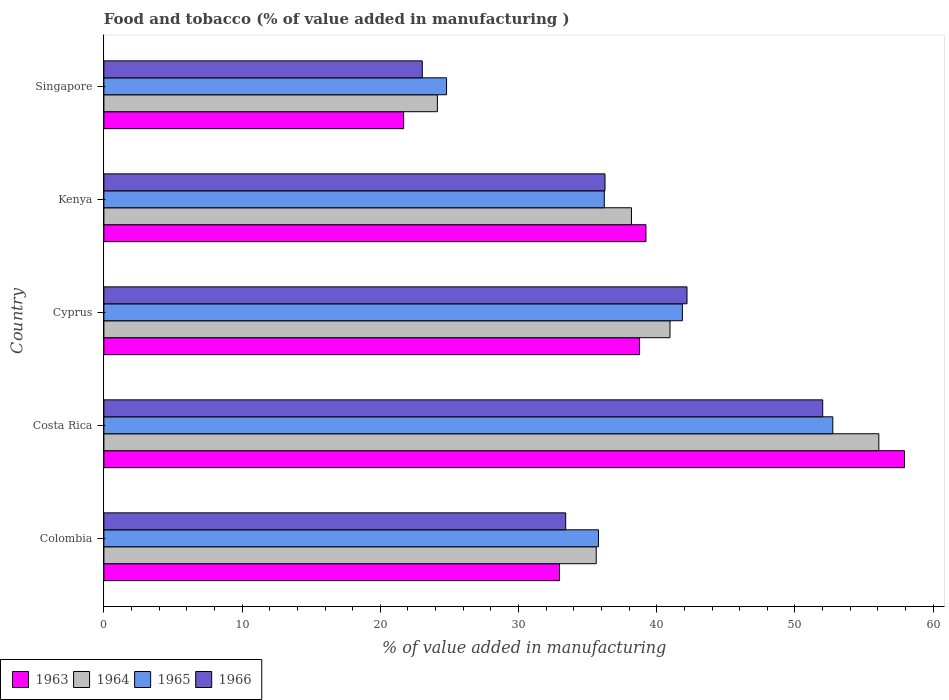How many different coloured bars are there?
Your answer should be compact. 4. Are the number of bars on each tick of the Y-axis equal?
Your answer should be compact. Yes. In how many cases, is the number of bars for a given country not equal to the number of legend labels?
Ensure brevity in your answer.  0. What is the value added in manufacturing food and tobacco in 1963 in Kenya?
Provide a short and direct response. 39.22. Across all countries, what is the maximum value added in manufacturing food and tobacco in 1966?
Keep it short and to the point. 52. Across all countries, what is the minimum value added in manufacturing food and tobacco in 1965?
Ensure brevity in your answer.  24.79. In which country was the value added in manufacturing food and tobacco in 1963 maximum?
Give a very brief answer. Costa Rica. In which country was the value added in manufacturing food and tobacco in 1965 minimum?
Your answer should be compact. Singapore. What is the total value added in manufacturing food and tobacco in 1964 in the graph?
Ensure brevity in your answer.  194.94. What is the difference between the value added in manufacturing food and tobacco in 1965 in Costa Rica and that in Kenya?
Provide a short and direct response. 16.53. What is the difference between the value added in manufacturing food and tobacco in 1964 in Cyprus and the value added in manufacturing food and tobacco in 1963 in Kenya?
Your response must be concise. 1.74. What is the average value added in manufacturing food and tobacco in 1966 per country?
Your answer should be very brief. 37.38. What is the difference between the value added in manufacturing food and tobacco in 1966 and value added in manufacturing food and tobacco in 1964 in Costa Rica?
Make the answer very short. -4.06. In how many countries, is the value added in manufacturing food and tobacco in 1963 greater than 34 %?
Your answer should be very brief. 3. What is the ratio of the value added in manufacturing food and tobacco in 1966 in Cyprus to that in Kenya?
Make the answer very short. 1.16. Is the value added in manufacturing food and tobacco in 1963 in Colombia less than that in Singapore?
Make the answer very short. No. Is the difference between the value added in manufacturing food and tobacco in 1966 in Colombia and Singapore greater than the difference between the value added in manufacturing food and tobacco in 1964 in Colombia and Singapore?
Ensure brevity in your answer.  No. What is the difference between the highest and the second highest value added in manufacturing food and tobacco in 1965?
Offer a terse response. 10.88. What is the difference between the highest and the lowest value added in manufacturing food and tobacco in 1964?
Make the answer very short. 31.94. Is the sum of the value added in manufacturing food and tobacco in 1965 in Cyprus and Kenya greater than the maximum value added in manufacturing food and tobacco in 1964 across all countries?
Your answer should be very brief. Yes. Is it the case that in every country, the sum of the value added in manufacturing food and tobacco in 1966 and value added in manufacturing food and tobacco in 1964 is greater than the sum of value added in manufacturing food and tobacco in 1963 and value added in manufacturing food and tobacco in 1965?
Your response must be concise. No. What does the 2nd bar from the top in Kenya represents?
Give a very brief answer. 1965. What does the 3rd bar from the bottom in Colombia represents?
Ensure brevity in your answer.  1965. Is it the case that in every country, the sum of the value added in manufacturing food and tobacco in 1964 and value added in manufacturing food and tobacco in 1963 is greater than the value added in manufacturing food and tobacco in 1965?
Offer a very short reply. Yes. How many bars are there?
Ensure brevity in your answer.  20. How many countries are there in the graph?
Offer a very short reply. 5. Are the values on the major ticks of X-axis written in scientific E-notation?
Offer a very short reply. No. Does the graph contain grids?
Make the answer very short. No. How many legend labels are there?
Provide a short and direct response. 4. What is the title of the graph?
Your answer should be compact. Food and tobacco (% of value added in manufacturing ). Does "2010" appear as one of the legend labels in the graph?
Provide a succinct answer. No. What is the label or title of the X-axis?
Provide a short and direct response. % of value added in manufacturing. What is the % of value added in manufacturing of 1963 in Colombia?
Your answer should be compact. 32.96. What is the % of value added in manufacturing of 1964 in Colombia?
Ensure brevity in your answer.  35.62. What is the % of value added in manufacturing in 1965 in Colombia?
Your answer should be compact. 35.78. What is the % of value added in manufacturing in 1966 in Colombia?
Offer a terse response. 33.41. What is the % of value added in manufacturing in 1963 in Costa Rica?
Offer a very short reply. 57.92. What is the % of value added in manufacturing in 1964 in Costa Rica?
Ensure brevity in your answer.  56.07. What is the % of value added in manufacturing of 1965 in Costa Rica?
Ensure brevity in your answer.  52.73. What is the % of value added in manufacturing in 1966 in Costa Rica?
Your answer should be very brief. 52. What is the % of value added in manufacturing in 1963 in Cyprus?
Your answer should be compact. 38.75. What is the % of value added in manufacturing of 1964 in Cyprus?
Your answer should be very brief. 40.96. What is the % of value added in manufacturing in 1965 in Cyprus?
Provide a short and direct response. 41.85. What is the % of value added in manufacturing of 1966 in Cyprus?
Provide a succinct answer. 42.19. What is the % of value added in manufacturing in 1963 in Kenya?
Your answer should be compact. 39.22. What is the % of value added in manufacturing of 1964 in Kenya?
Keep it short and to the point. 38.17. What is the % of value added in manufacturing in 1965 in Kenya?
Keep it short and to the point. 36.2. What is the % of value added in manufacturing in 1966 in Kenya?
Your answer should be very brief. 36.25. What is the % of value added in manufacturing of 1963 in Singapore?
Your response must be concise. 21.69. What is the % of value added in manufacturing of 1964 in Singapore?
Offer a terse response. 24.13. What is the % of value added in manufacturing in 1965 in Singapore?
Your answer should be compact. 24.79. What is the % of value added in manufacturing in 1966 in Singapore?
Your answer should be very brief. 23.04. Across all countries, what is the maximum % of value added in manufacturing in 1963?
Keep it short and to the point. 57.92. Across all countries, what is the maximum % of value added in manufacturing of 1964?
Keep it short and to the point. 56.07. Across all countries, what is the maximum % of value added in manufacturing in 1965?
Your answer should be very brief. 52.73. Across all countries, what is the maximum % of value added in manufacturing of 1966?
Ensure brevity in your answer.  52. Across all countries, what is the minimum % of value added in manufacturing in 1963?
Ensure brevity in your answer.  21.69. Across all countries, what is the minimum % of value added in manufacturing of 1964?
Your answer should be very brief. 24.13. Across all countries, what is the minimum % of value added in manufacturing in 1965?
Provide a succinct answer. 24.79. Across all countries, what is the minimum % of value added in manufacturing in 1966?
Offer a terse response. 23.04. What is the total % of value added in manufacturing in 1963 in the graph?
Keep it short and to the point. 190.54. What is the total % of value added in manufacturing in 1964 in the graph?
Your response must be concise. 194.94. What is the total % of value added in manufacturing in 1965 in the graph?
Keep it short and to the point. 191.36. What is the total % of value added in manufacturing of 1966 in the graph?
Give a very brief answer. 186.89. What is the difference between the % of value added in manufacturing in 1963 in Colombia and that in Costa Rica?
Your response must be concise. -24.96. What is the difference between the % of value added in manufacturing in 1964 in Colombia and that in Costa Rica?
Provide a succinct answer. -20.45. What is the difference between the % of value added in manufacturing in 1965 in Colombia and that in Costa Rica?
Your answer should be compact. -16.95. What is the difference between the % of value added in manufacturing of 1966 in Colombia and that in Costa Rica?
Keep it short and to the point. -18.59. What is the difference between the % of value added in manufacturing in 1963 in Colombia and that in Cyprus?
Your response must be concise. -5.79. What is the difference between the % of value added in manufacturing in 1964 in Colombia and that in Cyprus?
Your answer should be compact. -5.34. What is the difference between the % of value added in manufacturing in 1965 in Colombia and that in Cyprus?
Offer a terse response. -6.07. What is the difference between the % of value added in manufacturing in 1966 in Colombia and that in Cyprus?
Your response must be concise. -8.78. What is the difference between the % of value added in manufacturing of 1963 in Colombia and that in Kenya?
Offer a very short reply. -6.26. What is the difference between the % of value added in manufacturing of 1964 in Colombia and that in Kenya?
Provide a short and direct response. -2.55. What is the difference between the % of value added in manufacturing of 1965 in Colombia and that in Kenya?
Your answer should be very brief. -0.42. What is the difference between the % of value added in manufacturing in 1966 in Colombia and that in Kenya?
Your answer should be compact. -2.84. What is the difference between the % of value added in manufacturing in 1963 in Colombia and that in Singapore?
Your response must be concise. 11.27. What is the difference between the % of value added in manufacturing in 1964 in Colombia and that in Singapore?
Your answer should be compact. 11.49. What is the difference between the % of value added in manufacturing of 1965 in Colombia and that in Singapore?
Provide a short and direct response. 10.99. What is the difference between the % of value added in manufacturing in 1966 in Colombia and that in Singapore?
Your answer should be compact. 10.37. What is the difference between the % of value added in manufacturing in 1963 in Costa Rica and that in Cyprus?
Provide a short and direct response. 19.17. What is the difference between the % of value added in manufacturing in 1964 in Costa Rica and that in Cyprus?
Keep it short and to the point. 15.11. What is the difference between the % of value added in manufacturing of 1965 in Costa Rica and that in Cyprus?
Your answer should be compact. 10.88. What is the difference between the % of value added in manufacturing of 1966 in Costa Rica and that in Cyprus?
Keep it short and to the point. 9.82. What is the difference between the % of value added in manufacturing in 1963 in Costa Rica and that in Kenya?
Provide a succinct answer. 18.7. What is the difference between the % of value added in manufacturing in 1964 in Costa Rica and that in Kenya?
Your answer should be very brief. 17.9. What is the difference between the % of value added in manufacturing in 1965 in Costa Rica and that in Kenya?
Offer a terse response. 16.53. What is the difference between the % of value added in manufacturing in 1966 in Costa Rica and that in Kenya?
Offer a terse response. 15.75. What is the difference between the % of value added in manufacturing of 1963 in Costa Rica and that in Singapore?
Offer a very short reply. 36.23. What is the difference between the % of value added in manufacturing of 1964 in Costa Rica and that in Singapore?
Your response must be concise. 31.94. What is the difference between the % of value added in manufacturing in 1965 in Costa Rica and that in Singapore?
Ensure brevity in your answer.  27.94. What is the difference between the % of value added in manufacturing in 1966 in Costa Rica and that in Singapore?
Make the answer very short. 28.97. What is the difference between the % of value added in manufacturing of 1963 in Cyprus and that in Kenya?
Make the answer very short. -0.46. What is the difference between the % of value added in manufacturing in 1964 in Cyprus and that in Kenya?
Offer a terse response. 2.79. What is the difference between the % of value added in manufacturing of 1965 in Cyprus and that in Kenya?
Your answer should be compact. 5.65. What is the difference between the % of value added in manufacturing of 1966 in Cyprus and that in Kenya?
Your answer should be compact. 5.93. What is the difference between the % of value added in manufacturing of 1963 in Cyprus and that in Singapore?
Your answer should be compact. 17.07. What is the difference between the % of value added in manufacturing of 1964 in Cyprus and that in Singapore?
Your answer should be very brief. 16.83. What is the difference between the % of value added in manufacturing in 1965 in Cyprus and that in Singapore?
Make the answer very short. 17.06. What is the difference between the % of value added in manufacturing of 1966 in Cyprus and that in Singapore?
Give a very brief answer. 19.15. What is the difference between the % of value added in manufacturing of 1963 in Kenya and that in Singapore?
Keep it short and to the point. 17.53. What is the difference between the % of value added in manufacturing in 1964 in Kenya and that in Singapore?
Your answer should be compact. 14.04. What is the difference between the % of value added in manufacturing in 1965 in Kenya and that in Singapore?
Your response must be concise. 11.41. What is the difference between the % of value added in manufacturing in 1966 in Kenya and that in Singapore?
Your response must be concise. 13.22. What is the difference between the % of value added in manufacturing in 1963 in Colombia and the % of value added in manufacturing in 1964 in Costa Rica?
Your answer should be compact. -23.11. What is the difference between the % of value added in manufacturing in 1963 in Colombia and the % of value added in manufacturing in 1965 in Costa Rica?
Ensure brevity in your answer.  -19.77. What is the difference between the % of value added in manufacturing of 1963 in Colombia and the % of value added in manufacturing of 1966 in Costa Rica?
Give a very brief answer. -19.04. What is the difference between the % of value added in manufacturing in 1964 in Colombia and the % of value added in manufacturing in 1965 in Costa Rica?
Offer a very short reply. -17.11. What is the difference between the % of value added in manufacturing in 1964 in Colombia and the % of value added in manufacturing in 1966 in Costa Rica?
Provide a succinct answer. -16.38. What is the difference between the % of value added in manufacturing of 1965 in Colombia and the % of value added in manufacturing of 1966 in Costa Rica?
Provide a succinct answer. -16.22. What is the difference between the % of value added in manufacturing in 1963 in Colombia and the % of value added in manufacturing in 1964 in Cyprus?
Keep it short and to the point. -8. What is the difference between the % of value added in manufacturing in 1963 in Colombia and the % of value added in manufacturing in 1965 in Cyprus?
Offer a very short reply. -8.89. What is the difference between the % of value added in manufacturing of 1963 in Colombia and the % of value added in manufacturing of 1966 in Cyprus?
Your answer should be very brief. -9.23. What is the difference between the % of value added in manufacturing in 1964 in Colombia and the % of value added in manufacturing in 1965 in Cyprus?
Make the answer very short. -6.23. What is the difference between the % of value added in manufacturing in 1964 in Colombia and the % of value added in manufacturing in 1966 in Cyprus?
Your answer should be very brief. -6.57. What is the difference between the % of value added in manufacturing of 1965 in Colombia and the % of value added in manufacturing of 1966 in Cyprus?
Your answer should be compact. -6.41. What is the difference between the % of value added in manufacturing of 1963 in Colombia and the % of value added in manufacturing of 1964 in Kenya?
Offer a very short reply. -5.21. What is the difference between the % of value added in manufacturing in 1963 in Colombia and the % of value added in manufacturing in 1965 in Kenya?
Make the answer very short. -3.24. What is the difference between the % of value added in manufacturing in 1963 in Colombia and the % of value added in manufacturing in 1966 in Kenya?
Keep it short and to the point. -3.29. What is the difference between the % of value added in manufacturing in 1964 in Colombia and the % of value added in manufacturing in 1965 in Kenya?
Offer a terse response. -0.58. What is the difference between the % of value added in manufacturing of 1964 in Colombia and the % of value added in manufacturing of 1966 in Kenya?
Make the answer very short. -0.63. What is the difference between the % of value added in manufacturing in 1965 in Colombia and the % of value added in manufacturing in 1966 in Kenya?
Provide a succinct answer. -0.47. What is the difference between the % of value added in manufacturing of 1963 in Colombia and the % of value added in manufacturing of 1964 in Singapore?
Your answer should be compact. 8.83. What is the difference between the % of value added in manufacturing in 1963 in Colombia and the % of value added in manufacturing in 1965 in Singapore?
Ensure brevity in your answer.  8.17. What is the difference between the % of value added in manufacturing of 1963 in Colombia and the % of value added in manufacturing of 1966 in Singapore?
Provide a succinct answer. 9.92. What is the difference between the % of value added in manufacturing of 1964 in Colombia and the % of value added in manufacturing of 1965 in Singapore?
Make the answer very short. 10.83. What is the difference between the % of value added in manufacturing of 1964 in Colombia and the % of value added in manufacturing of 1966 in Singapore?
Your response must be concise. 12.58. What is the difference between the % of value added in manufacturing in 1965 in Colombia and the % of value added in manufacturing in 1966 in Singapore?
Make the answer very short. 12.74. What is the difference between the % of value added in manufacturing in 1963 in Costa Rica and the % of value added in manufacturing in 1964 in Cyprus?
Your answer should be compact. 16.96. What is the difference between the % of value added in manufacturing of 1963 in Costa Rica and the % of value added in manufacturing of 1965 in Cyprus?
Give a very brief answer. 16.07. What is the difference between the % of value added in manufacturing of 1963 in Costa Rica and the % of value added in manufacturing of 1966 in Cyprus?
Your answer should be compact. 15.73. What is the difference between the % of value added in manufacturing in 1964 in Costa Rica and the % of value added in manufacturing in 1965 in Cyprus?
Offer a very short reply. 14.21. What is the difference between the % of value added in manufacturing in 1964 in Costa Rica and the % of value added in manufacturing in 1966 in Cyprus?
Provide a short and direct response. 13.88. What is the difference between the % of value added in manufacturing of 1965 in Costa Rica and the % of value added in manufacturing of 1966 in Cyprus?
Your response must be concise. 10.55. What is the difference between the % of value added in manufacturing of 1963 in Costa Rica and the % of value added in manufacturing of 1964 in Kenya?
Offer a very short reply. 19.75. What is the difference between the % of value added in manufacturing of 1963 in Costa Rica and the % of value added in manufacturing of 1965 in Kenya?
Provide a short and direct response. 21.72. What is the difference between the % of value added in manufacturing of 1963 in Costa Rica and the % of value added in manufacturing of 1966 in Kenya?
Offer a very short reply. 21.67. What is the difference between the % of value added in manufacturing of 1964 in Costa Rica and the % of value added in manufacturing of 1965 in Kenya?
Your response must be concise. 19.86. What is the difference between the % of value added in manufacturing of 1964 in Costa Rica and the % of value added in manufacturing of 1966 in Kenya?
Offer a very short reply. 19.81. What is the difference between the % of value added in manufacturing of 1965 in Costa Rica and the % of value added in manufacturing of 1966 in Kenya?
Make the answer very short. 16.48. What is the difference between the % of value added in manufacturing in 1963 in Costa Rica and the % of value added in manufacturing in 1964 in Singapore?
Offer a very short reply. 33.79. What is the difference between the % of value added in manufacturing of 1963 in Costa Rica and the % of value added in manufacturing of 1965 in Singapore?
Offer a very short reply. 33.13. What is the difference between the % of value added in manufacturing of 1963 in Costa Rica and the % of value added in manufacturing of 1966 in Singapore?
Make the answer very short. 34.88. What is the difference between the % of value added in manufacturing of 1964 in Costa Rica and the % of value added in manufacturing of 1965 in Singapore?
Keep it short and to the point. 31.28. What is the difference between the % of value added in manufacturing in 1964 in Costa Rica and the % of value added in manufacturing in 1966 in Singapore?
Your answer should be compact. 33.03. What is the difference between the % of value added in manufacturing in 1965 in Costa Rica and the % of value added in manufacturing in 1966 in Singapore?
Your answer should be very brief. 29.7. What is the difference between the % of value added in manufacturing of 1963 in Cyprus and the % of value added in manufacturing of 1964 in Kenya?
Give a very brief answer. 0.59. What is the difference between the % of value added in manufacturing in 1963 in Cyprus and the % of value added in manufacturing in 1965 in Kenya?
Ensure brevity in your answer.  2.55. What is the difference between the % of value added in manufacturing of 1963 in Cyprus and the % of value added in manufacturing of 1966 in Kenya?
Keep it short and to the point. 2.5. What is the difference between the % of value added in manufacturing of 1964 in Cyprus and the % of value added in manufacturing of 1965 in Kenya?
Offer a very short reply. 4.75. What is the difference between the % of value added in manufacturing of 1964 in Cyprus and the % of value added in manufacturing of 1966 in Kenya?
Your response must be concise. 4.7. What is the difference between the % of value added in manufacturing in 1965 in Cyprus and the % of value added in manufacturing in 1966 in Kenya?
Ensure brevity in your answer.  5.6. What is the difference between the % of value added in manufacturing of 1963 in Cyprus and the % of value added in manufacturing of 1964 in Singapore?
Provide a short and direct response. 14.63. What is the difference between the % of value added in manufacturing of 1963 in Cyprus and the % of value added in manufacturing of 1965 in Singapore?
Make the answer very short. 13.96. What is the difference between the % of value added in manufacturing of 1963 in Cyprus and the % of value added in manufacturing of 1966 in Singapore?
Your answer should be compact. 15.72. What is the difference between the % of value added in manufacturing in 1964 in Cyprus and the % of value added in manufacturing in 1965 in Singapore?
Provide a succinct answer. 16.17. What is the difference between the % of value added in manufacturing in 1964 in Cyprus and the % of value added in manufacturing in 1966 in Singapore?
Your response must be concise. 17.92. What is the difference between the % of value added in manufacturing of 1965 in Cyprus and the % of value added in manufacturing of 1966 in Singapore?
Make the answer very short. 18.82. What is the difference between the % of value added in manufacturing of 1963 in Kenya and the % of value added in manufacturing of 1964 in Singapore?
Your response must be concise. 15.09. What is the difference between the % of value added in manufacturing of 1963 in Kenya and the % of value added in manufacturing of 1965 in Singapore?
Provide a succinct answer. 14.43. What is the difference between the % of value added in manufacturing of 1963 in Kenya and the % of value added in manufacturing of 1966 in Singapore?
Provide a short and direct response. 16.18. What is the difference between the % of value added in manufacturing of 1964 in Kenya and the % of value added in manufacturing of 1965 in Singapore?
Keep it short and to the point. 13.38. What is the difference between the % of value added in manufacturing of 1964 in Kenya and the % of value added in manufacturing of 1966 in Singapore?
Keep it short and to the point. 15.13. What is the difference between the % of value added in manufacturing in 1965 in Kenya and the % of value added in manufacturing in 1966 in Singapore?
Make the answer very short. 13.17. What is the average % of value added in manufacturing in 1963 per country?
Offer a very short reply. 38.11. What is the average % of value added in manufacturing of 1964 per country?
Your response must be concise. 38.99. What is the average % of value added in manufacturing in 1965 per country?
Your answer should be very brief. 38.27. What is the average % of value added in manufacturing in 1966 per country?
Make the answer very short. 37.38. What is the difference between the % of value added in manufacturing of 1963 and % of value added in manufacturing of 1964 in Colombia?
Your answer should be very brief. -2.66. What is the difference between the % of value added in manufacturing in 1963 and % of value added in manufacturing in 1965 in Colombia?
Give a very brief answer. -2.82. What is the difference between the % of value added in manufacturing of 1963 and % of value added in manufacturing of 1966 in Colombia?
Keep it short and to the point. -0.45. What is the difference between the % of value added in manufacturing in 1964 and % of value added in manufacturing in 1965 in Colombia?
Ensure brevity in your answer.  -0.16. What is the difference between the % of value added in manufacturing in 1964 and % of value added in manufacturing in 1966 in Colombia?
Ensure brevity in your answer.  2.21. What is the difference between the % of value added in manufacturing in 1965 and % of value added in manufacturing in 1966 in Colombia?
Make the answer very short. 2.37. What is the difference between the % of value added in manufacturing of 1963 and % of value added in manufacturing of 1964 in Costa Rica?
Provide a succinct answer. 1.85. What is the difference between the % of value added in manufacturing of 1963 and % of value added in manufacturing of 1965 in Costa Rica?
Provide a succinct answer. 5.19. What is the difference between the % of value added in manufacturing of 1963 and % of value added in manufacturing of 1966 in Costa Rica?
Your answer should be very brief. 5.92. What is the difference between the % of value added in manufacturing of 1964 and % of value added in manufacturing of 1965 in Costa Rica?
Ensure brevity in your answer.  3.33. What is the difference between the % of value added in manufacturing in 1964 and % of value added in manufacturing in 1966 in Costa Rica?
Your answer should be very brief. 4.06. What is the difference between the % of value added in manufacturing in 1965 and % of value added in manufacturing in 1966 in Costa Rica?
Give a very brief answer. 0.73. What is the difference between the % of value added in manufacturing in 1963 and % of value added in manufacturing in 1964 in Cyprus?
Keep it short and to the point. -2.2. What is the difference between the % of value added in manufacturing in 1963 and % of value added in manufacturing in 1965 in Cyprus?
Offer a terse response. -3.1. What is the difference between the % of value added in manufacturing in 1963 and % of value added in manufacturing in 1966 in Cyprus?
Ensure brevity in your answer.  -3.43. What is the difference between the % of value added in manufacturing in 1964 and % of value added in manufacturing in 1965 in Cyprus?
Your answer should be compact. -0.9. What is the difference between the % of value added in manufacturing of 1964 and % of value added in manufacturing of 1966 in Cyprus?
Your answer should be compact. -1.23. What is the difference between the % of value added in manufacturing of 1965 and % of value added in manufacturing of 1966 in Cyprus?
Make the answer very short. -0.33. What is the difference between the % of value added in manufacturing in 1963 and % of value added in manufacturing in 1964 in Kenya?
Offer a very short reply. 1.05. What is the difference between the % of value added in manufacturing in 1963 and % of value added in manufacturing in 1965 in Kenya?
Keep it short and to the point. 3.01. What is the difference between the % of value added in manufacturing of 1963 and % of value added in manufacturing of 1966 in Kenya?
Ensure brevity in your answer.  2.96. What is the difference between the % of value added in manufacturing in 1964 and % of value added in manufacturing in 1965 in Kenya?
Keep it short and to the point. 1.96. What is the difference between the % of value added in manufacturing in 1964 and % of value added in manufacturing in 1966 in Kenya?
Ensure brevity in your answer.  1.91. What is the difference between the % of value added in manufacturing in 1963 and % of value added in manufacturing in 1964 in Singapore?
Your response must be concise. -2.44. What is the difference between the % of value added in manufacturing in 1963 and % of value added in manufacturing in 1965 in Singapore?
Provide a short and direct response. -3.1. What is the difference between the % of value added in manufacturing of 1963 and % of value added in manufacturing of 1966 in Singapore?
Keep it short and to the point. -1.35. What is the difference between the % of value added in manufacturing of 1964 and % of value added in manufacturing of 1965 in Singapore?
Provide a succinct answer. -0.66. What is the difference between the % of value added in manufacturing of 1964 and % of value added in manufacturing of 1966 in Singapore?
Give a very brief answer. 1.09. What is the difference between the % of value added in manufacturing of 1965 and % of value added in manufacturing of 1966 in Singapore?
Provide a short and direct response. 1.75. What is the ratio of the % of value added in manufacturing in 1963 in Colombia to that in Costa Rica?
Offer a terse response. 0.57. What is the ratio of the % of value added in manufacturing of 1964 in Colombia to that in Costa Rica?
Your response must be concise. 0.64. What is the ratio of the % of value added in manufacturing of 1965 in Colombia to that in Costa Rica?
Your response must be concise. 0.68. What is the ratio of the % of value added in manufacturing of 1966 in Colombia to that in Costa Rica?
Make the answer very short. 0.64. What is the ratio of the % of value added in manufacturing in 1963 in Colombia to that in Cyprus?
Make the answer very short. 0.85. What is the ratio of the % of value added in manufacturing in 1964 in Colombia to that in Cyprus?
Give a very brief answer. 0.87. What is the ratio of the % of value added in manufacturing of 1965 in Colombia to that in Cyprus?
Your answer should be compact. 0.85. What is the ratio of the % of value added in manufacturing in 1966 in Colombia to that in Cyprus?
Make the answer very short. 0.79. What is the ratio of the % of value added in manufacturing of 1963 in Colombia to that in Kenya?
Give a very brief answer. 0.84. What is the ratio of the % of value added in manufacturing in 1964 in Colombia to that in Kenya?
Give a very brief answer. 0.93. What is the ratio of the % of value added in manufacturing of 1965 in Colombia to that in Kenya?
Provide a short and direct response. 0.99. What is the ratio of the % of value added in manufacturing of 1966 in Colombia to that in Kenya?
Give a very brief answer. 0.92. What is the ratio of the % of value added in manufacturing in 1963 in Colombia to that in Singapore?
Your answer should be very brief. 1.52. What is the ratio of the % of value added in manufacturing in 1964 in Colombia to that in Singapore?
Provide a short and direct response. 1.48. What is the ratio of the % of value added in manufacturing in 1965 in Colombia to that in Singapore?
Ensure brevity in your answer.  1.44. What is the ratio of the % of value added in manufacturing of 1966 in Colombia to that in Singapore?
Give a very brief answer. 1.45. What is the ratio of the % of value added in manufacturing of 1963 in Costa Rica to that in Cyprus?
Your response must be concise. 1.49. What is the ratio of the % of value added in manufacturing in 1964 in Costa Rica to that in Cyprus?
Your response must be concise. 1.37. What is the ratio of the % of value added in manufacturing in 1965 in Costa Rica to that in Cyprus?
Offer a terse response. 1.26. What is the ratio of the % of value added in manufacturing in 1966 in Costa Rica to that in Cyprus?
Your response must be concise. 1.23. What is the ratio of the % of value added in manufacturing of 1963 in Costa Rica to that in Kenya?
Offer a very short reply. 1.48. What is the ratio of the % of value added in manufacturing in 1964 in Costa Rica to that in Kenya?
Offer a very short reply. 1.47. What is the ratio of the % of value added in manufacturing of 1965 in Costa Rica to that in Kenya?
Keep it short and to the point. 1.46. What is the ratio of the % of value added in manufacturing in 1966 in Costa Rica to that in Kenya?
Provide a succinct answer. 1.43. What is the ratio of the % of value added in manufacturing in 1963 in Costa Rica to that in Singapore?
Your answer should be compact. 2.67. What is the ratio of the % of value added in manufacturing in 1964 in Costa Rica to that in Singapore?
Provide a succinct answer. 2.32. What is the ratio of the % of value added in manufacturing in 1965 in Costa Rica to that in Singapore?
Ensure brevity in your answer.  2.13. What is the ratio of the % of value added in manufacturing in 1966 in Costa Rica to that in Singapore?
Make the answer very short. 2.26. What is the ratio of the % of value added in manufacturing in 1963 in Cyprus to that in Kenya?
Give a very brief answer. 0.99. What is the ratio of the % of value added in manufacturing of 1964 in Cyprus to that in Kenya?
Offer a terse response. 1.07. What is the ratio of the % of value added in manufacturing of 1965 in Cyprus to that in Kenya?
Make the answer very short. 1.16. What is the ratio of the % of value added in manufacturing of 1966 in Cyprus to that in Kenya?
Your answer should be very brief. 1.16. What is the ratio of the % of value added in manufacturing of 1963 in Cyprus to that in Singapore?
Your answer should be very brief. 1.79. What is the ratio of the % of value added in manufacturing of 1964 in Cyprus to that in Singapore?
Offer a very short reply. 1.7. What is the ratio of the % of value added in manufacturing of 1965 in Cyprus to that in Singapore?
Your answer should be compact. 1.69. What is the ratio of the % of value added in manufacturing of 1966 in Cyprus to that in Singapore?
Provide a succinct answer. 1.83. What is the ratio of the % of value added in manufacturing of 1963 in Kenya to that in Singapore?
Provide a succinct answer. 1.81. What is the ratio of the % of value added in manufacturing of 1964 in Kenya to that in Singapore?
Provide a short and direct response. 1.58. What is the ratio of the % of value added in manufacturing of 1965 in Kenya to that in Singapore?
Your response must be concise. 1.46. What is the ratio of the % of value added in manufacturing of 1966 in Kenya to that in Singapore?
Ensure brevity in your answer.  1.57. What is the difference between the highest and the second highest % of value added in manufacturing of 1963?
Give a very brief answer. 18.7. What is the difference between the highest and the second highest % of value added in manufacturing in 1964?
Provide a succinct answer. 15.11. What is the difference between the highest and the second highest % of value added in manufacturing of 1965?
Your answer should be compact. 10.88. What is the difference between the highest and the second highest % of value added in manufacturing of 1966?
Offer a very short reply. 9.82. What is the difference between the highest and the lowest % of value added in manufacturing in 1963?
Your response must be concise. 36.23. What is the difference between the highest and the lowest % of value added in manufacturing of 1964?
Keep it short and to the point. 31.94. What is the difference between the highest and the lowest % of value added in manufacturing in 1965?
Provide a succinct answer. 27.94. What is the difference between the highest and the lowest % of value added in manufacturing in 1966?
Give a very brief answer. 28.97. 